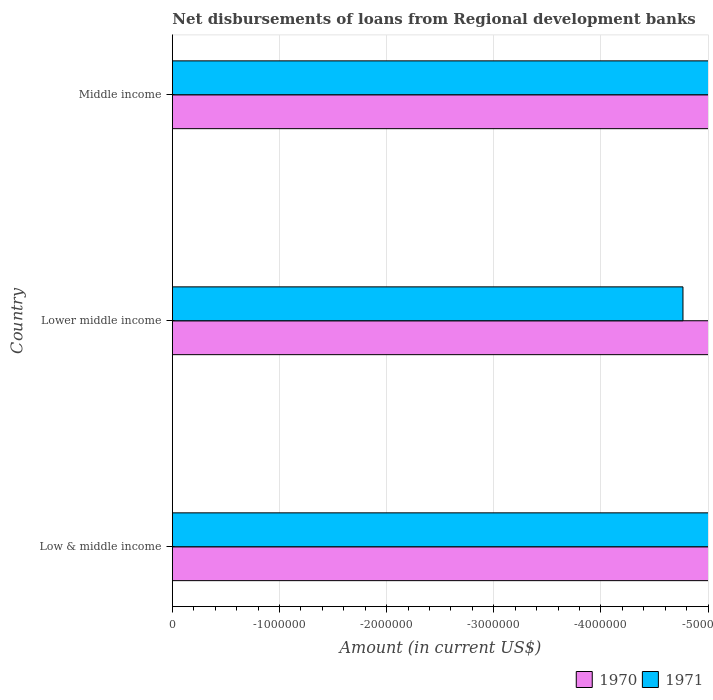Are the number of bars on each tick of the Y-axis equal?
Offer a very short reply. Yes. How many bars are there on the 2nd tick from the top?
Your answer should be very brief. 0. How many bars are there on the 2nd tick from the bottom?
Offer a very short reply. 0. What is the label of the 2nd group of bars from the top?
Provide a succinct answer. Lower middle income. Across all countries, what is the minimum amount of disbursements of loans from regional development banks in 1970?
Provide a short and direct response. 0. What is the total amount of disbursements of loans from regional development banks in 1970 in the graph?
Your answer should be very brief. 0. What is the difference between the amount of disbursements of loans from regional development banks in 1970 in Lower middle income and the amount of disbursements of loans from regional development banks in 1971 in Low & middle income?
Keep it short and to the point. 0. What is the average amount of disbursements of loans from regional development banks in 1971 per country?
Make the answer very short. 0. How many bars are there?
Provide a short and direct response. 0. Are all the bars in the graph horizontal?
Provide a succinct answer. Yes. What is the difference between two consecutive major ticks on the X-axis?
Your answer should be very brief. 1.00e+06. Does the graph contain any zero values?
Offer a terse response. Yes. Does the graph contain grids?
Provide a short and direct response. Yes. Where does the legend appear in the graph?
Your answer should be very brief. Bottom right. What is the title of the graph?
Offer a very short reply. Net disbursements of loans from Regional development banks. Does "1994" appear as one of the legend labels in the graph?
Your response must be concise. No. What is the Amount (in current US$) in 1971 in Lower middle income?
Keep it short and to the point. 0. What is the Amount (in current US$) of 1970 in Middle income?
Your answer should be very brief. 0. What is the Amount (in current US$) in 1971 in Middle income?
Offer a very short reply. 0. What is the total Amount (in current US$) in 1971 in the graph?
Give a very brief answer. 0. 